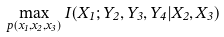<formula> <loc_0><loc_0><loc_500><loc_500>\max _ { p ( x _ { 1 } , x _ { 2 } , x _ { 3 } ) } I ( X _ { 1 } ; Y _ { 2 } , Y _ { 3 } , Y _ { 4 } | X _ { 2 } , X _ { 3 } )</formula> 